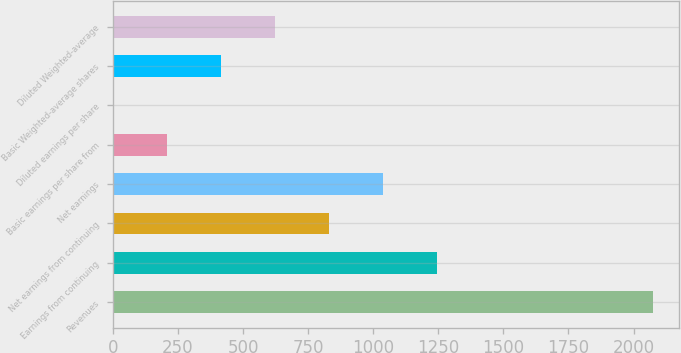<chart> <loc_0><loc_0><loc_500><loc_500><bar_chart><fcel>Revenues<fcel>Earnings from continuing<fcel>Net earnings from continuing<fcel>Net earnings<fcel>Basic earnings per share from<fcel>Diluted earnings per share<fcel>Basic Weighted-average shares<fcel>Diluted Weighted-average<nl><fcel>2073<fcel>1244.42<fcel>830.14<fcel>1037.28<fcel>208.72<fcel>1.58<fcel>415.86<fcel>623<nl></chart> 